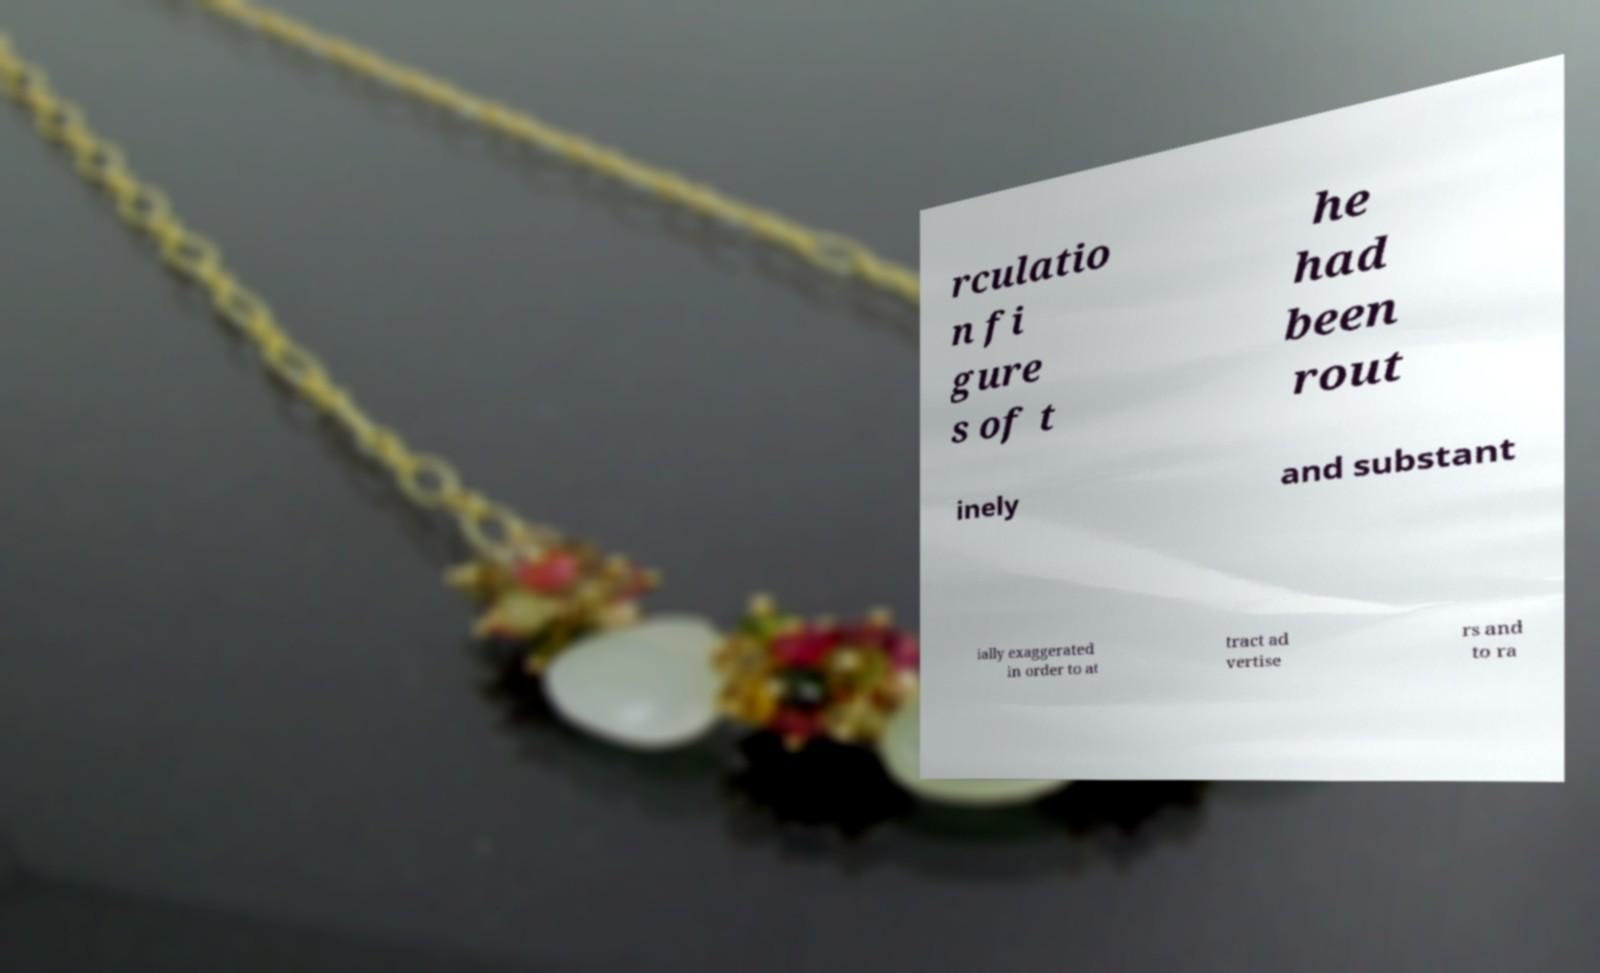I need the written content from this picture converted into text. Can you do that? rculatio n fi gure s of t he had been rout inely and substant ially exaggerated in order to at tract ad vertise rs and to ra 